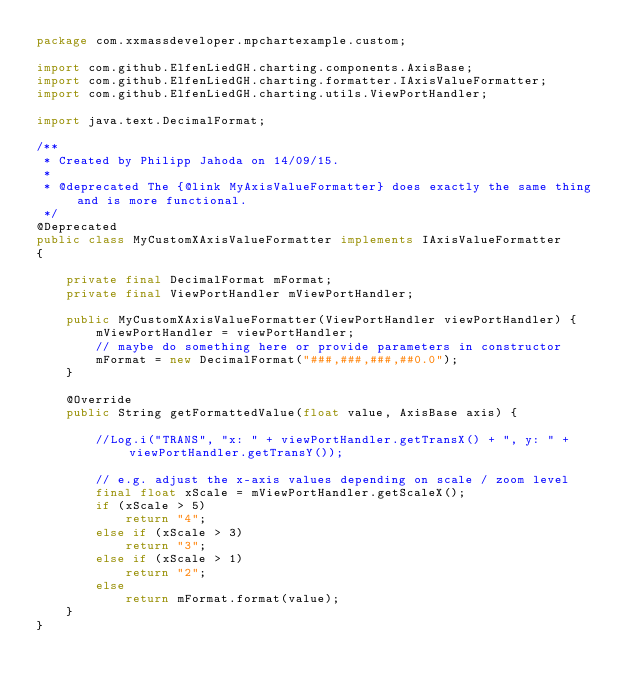<code> <loc_0><loc_0><loc_500><loc_500><_Java_>package com.xxmassdeveloper.mpchartexample.custom;

import com.github.ElfenLiedGH.charting.components.AxisBase;
import com.github.ElfenLiedGH.charting.formatter.IAxisValueFormatter;
import com.github.ElfenLiedGH.charting.utils.ViewPortHandler;

import java.text.DecimalFormat;

/**
 * Created by Philipp Jahoda on 14/09/15.
 *
 * @deprecated The {@link MyAxisValueFormatter} does exactly the same thing and is more functional.
 */
@Deprecated
public class MyCustomXAxisValueFormatter implements IAxisValueFormatter
{

    private final DecimalFormat mFormat;
    private final ViewPortHandler mViewPortHandler;

    public MyCustomXAxisValueFormatter(ViewPortHandler viewPortHandler) {
        mViewPortHandler = viewPortHandler;
        // maybe do something here or provide parameters in constructor
        mFormat = new DecimalFormat("###,###,###,##0.0");
    }

    @Override
    public String getFormattedValue(float value, AxisBase axis) {

        //Log.i("TRANS", "x: " + viewPortHandler.getTransX() + ", y: " + viewPortHandler.getTransY());

        // e.g. adjust the x-axis values depending on scale / zoom level
        final float xScale = mViewPortHandler.getScaleX();
        if (xScale > 5)
            return "4";
        else if (xScale > 3)
            return "3";
        else if (xScale > 1)
            return "2";
        else
            return mFormat.format(value);
    }
}
</code> 